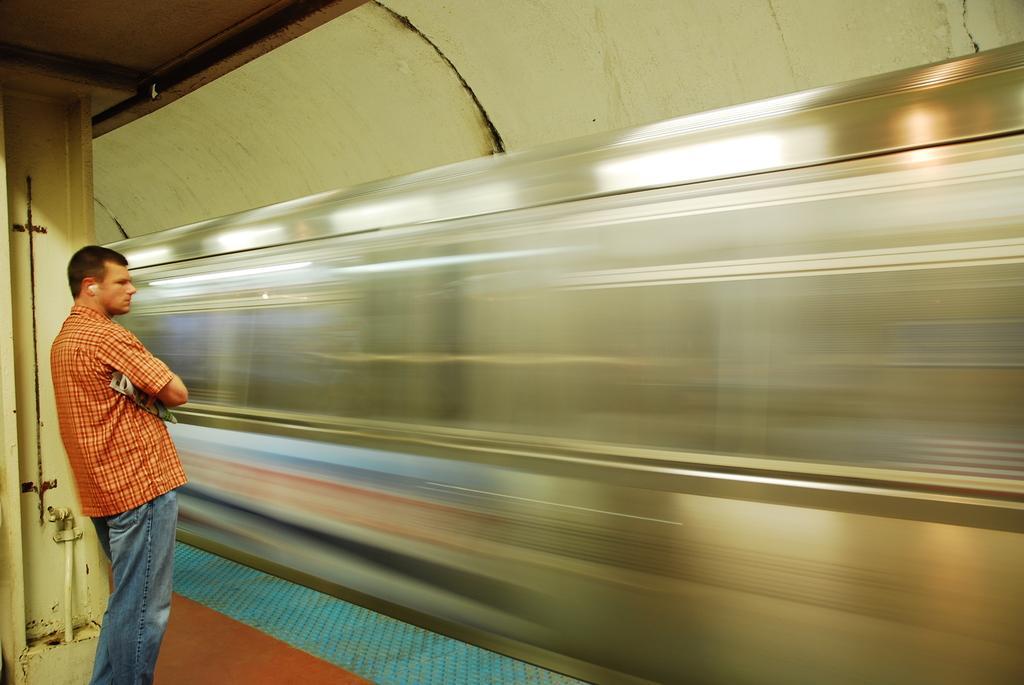How would you summarize this image in a sentence or two? In the picture I can see a man is standing and wearing a shirt and jeans. I can also see a train, a wall and some other objects. 